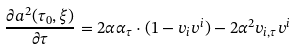<formula> <loc_0><loc_0><loc_500><loc_500>\frac { \partial a ^ { 2 } ( \tau _ { 0 } , \xi ) } { \partial \tau } = 2 \alpha \alpha _ { \tau } \cdot ( 1 - v _ { i } v ^ { i } ) - 2 \alpha ^ { 2 } v _ { i , \tau } v ^ { i }</formula> 